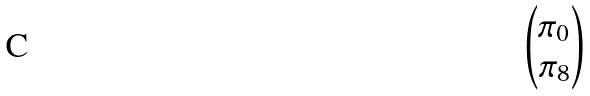<formula> <loc_0><loc_0><loc_500><loc_500>\begin{pmatrix} \pi _ { 0 } \\ \pi _ { 8 } \end{pmatrix}</formula> 